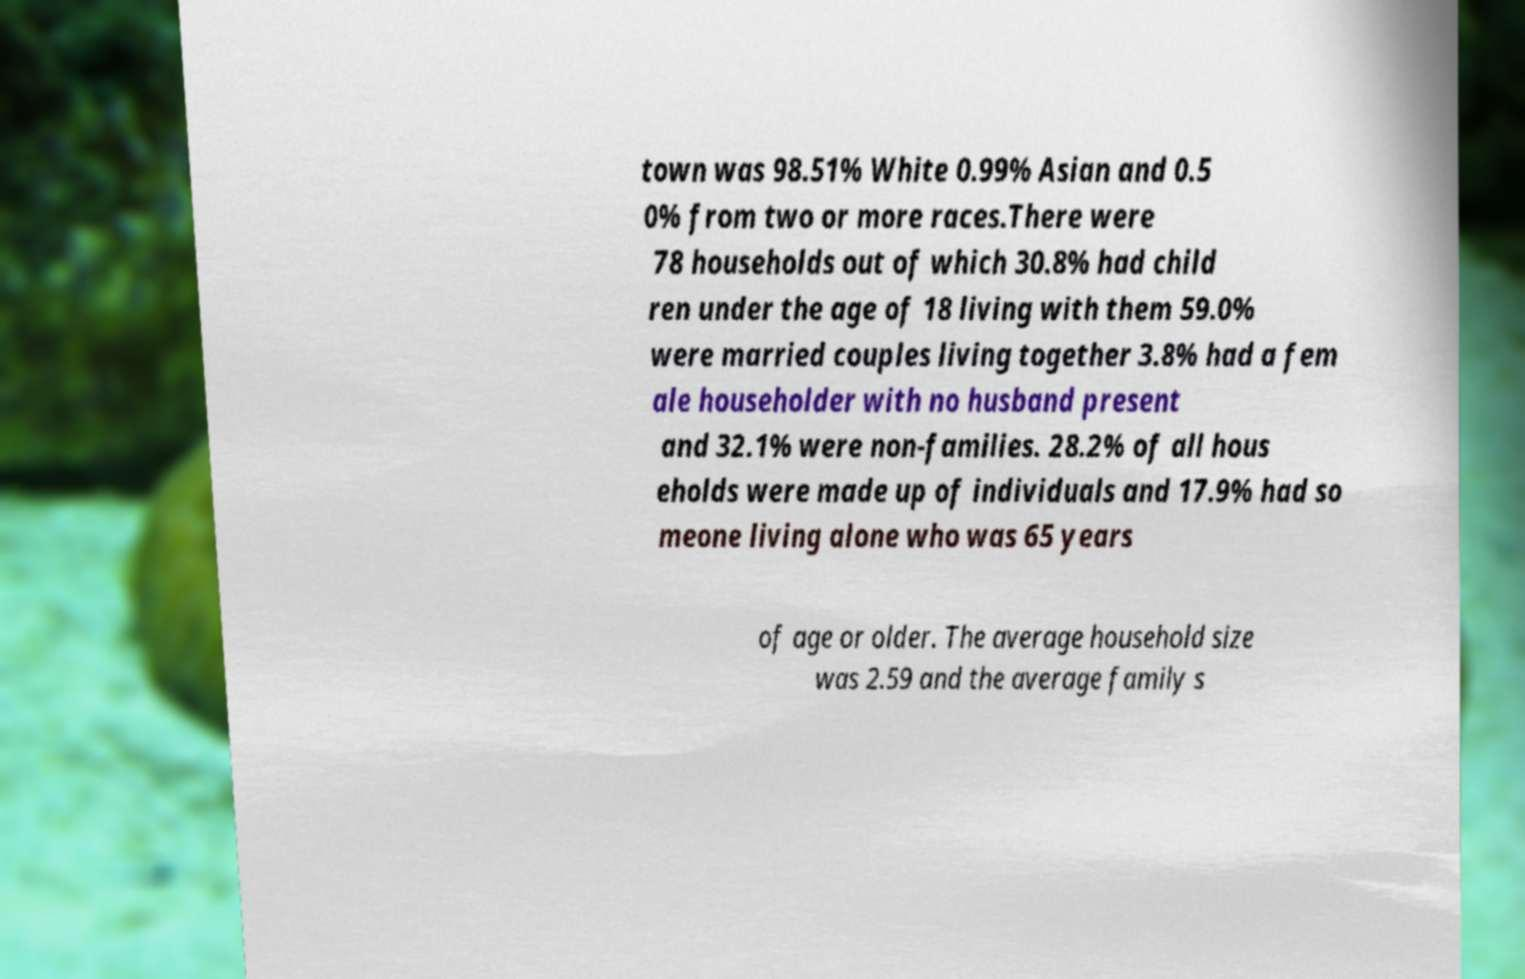Please identify and transcribe the text found in this image. town was 98.51% White 0.99% Asian and 0.5 0% from two or more races.There were 78 households out of which 30.8% had child ren under the age of 18 living with them 59.0% were married couples living together 3.8% had a fem ale householder with no husband present and 32.1% were non-families. 28.2% of all hous eholds were made up of individuals and 17.9% had so meone living alone who was 65 years of age or older. The average household size was 2.59 and the average family s 